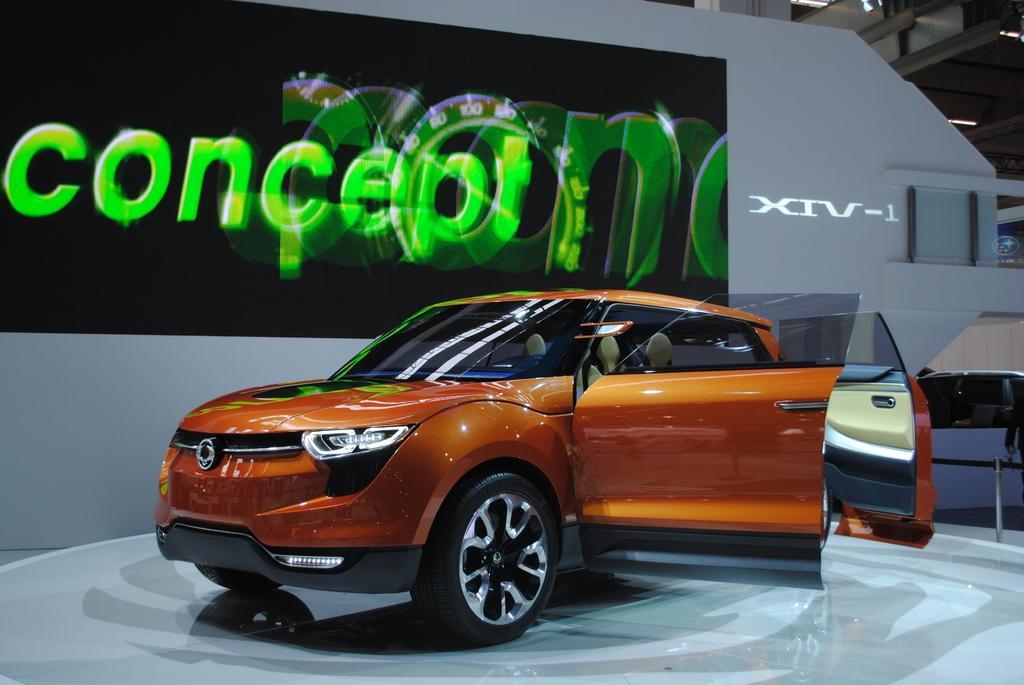How would you summarize this image in a sentence or two? In the foreground of this image, there is a car on the floor. In the background, there is a screen on the wall. At the top, there is a ceiling. On the right, it seems like another car in the background. 